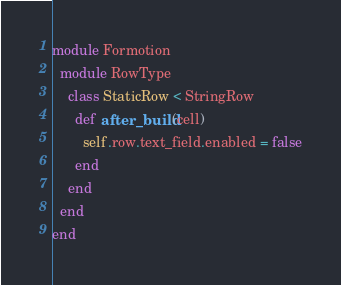Convert code to text. <code><loc_0><loc_0><loc_500><loc_500><_Ruby_>module Formotion
  module RowType
    class StaticRow < StringRow
      def after_build(cell)
        self.row.text_field.enabled = false
      end
    end
  end
end
</code> 